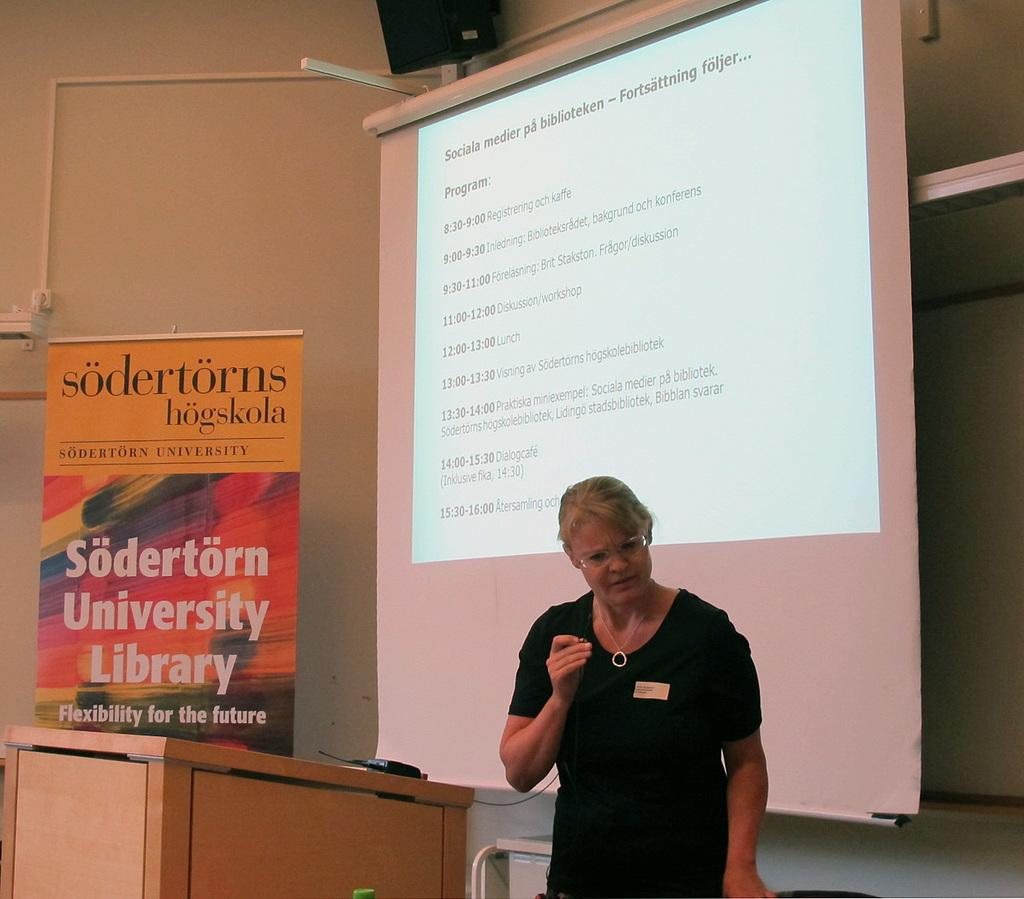<image>
Present a compact description of the photo's key features. a woman standing by a sign that says sodertorn university library 